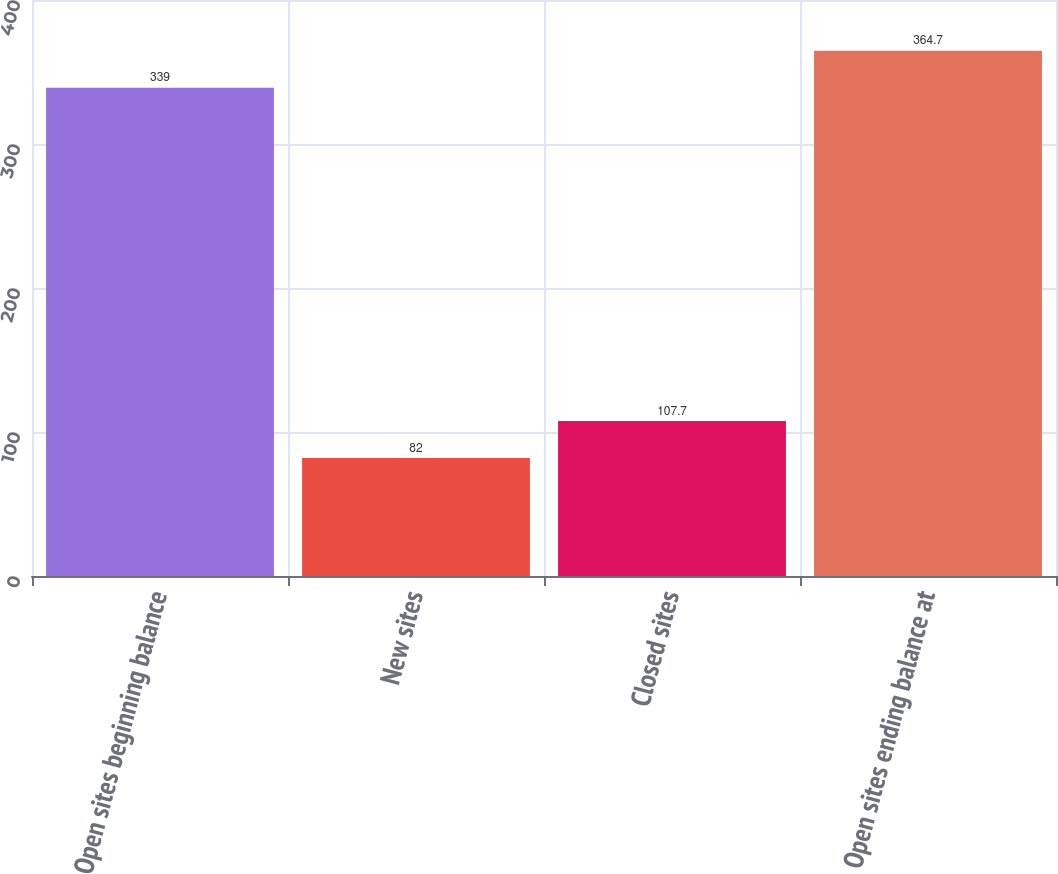Convert chart. <chart><loc_0><loc_0><loc_500><loc_500><bar_chart><fcel>Open sites beginning balance<fcel>New sites<fcel>Closed sites<fcel>Open sites ending balance at<nl><fcel>339<fcel>82<fcel>107.7<fcel>364.7<nl></chart> 